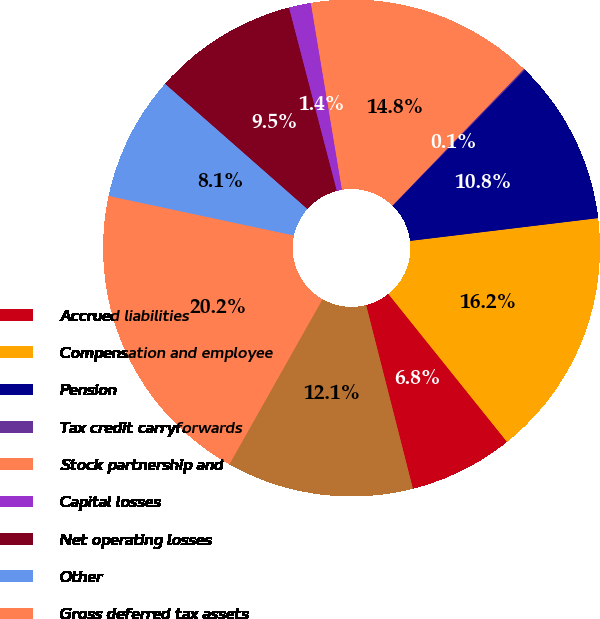<chart> <loc_0><loc_0><loc_500><loc_500><pie_chart><fcel>Accrued liabilities<fcel>Compensation and employee<fcel>Pension<fcel>Tax credit carryforwards<fcel>Stock partnership and<fcel>Capital losses<fcel>Net operating losses<fcel>Other<fcel>Gross deferred tax assets<fcel>Valuation allowance<nl><fcel>6.79%<fcel>16.16%<fcel>10.8%<fcel>0.09%<fcel>14.82%<fcel>1.43%<fcel>9.46%<fcel>8.13%<fcel>20.18%<fcel>12.14%<nl></chart> 